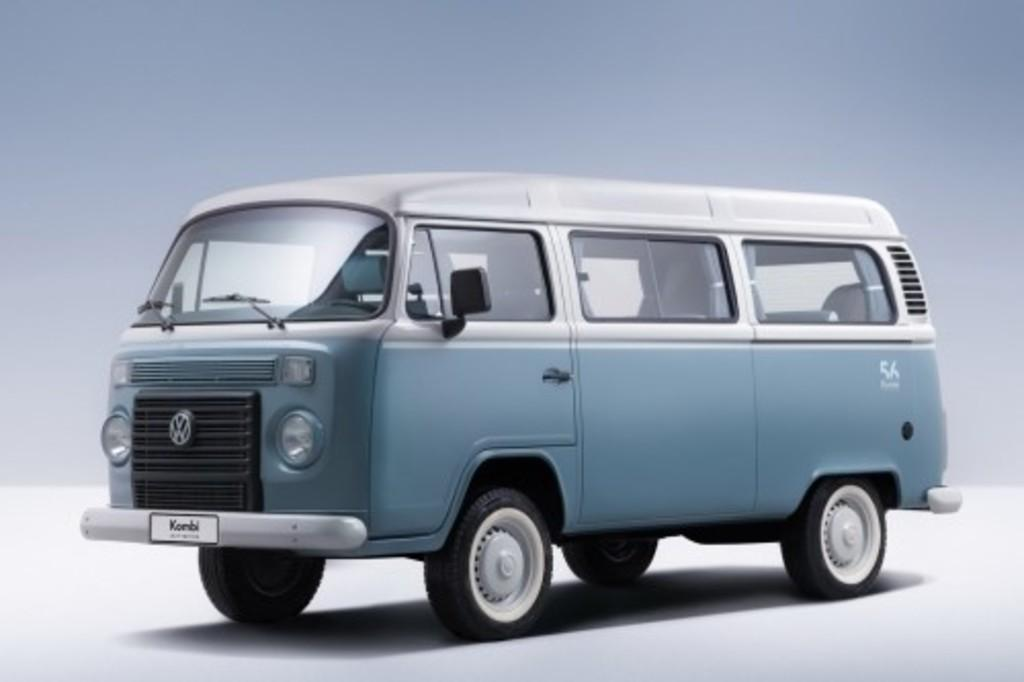Provide a one-sentence caption for the provided image. A blue Volkswagen van bears a difficult to discern logo starting with the letter K. 